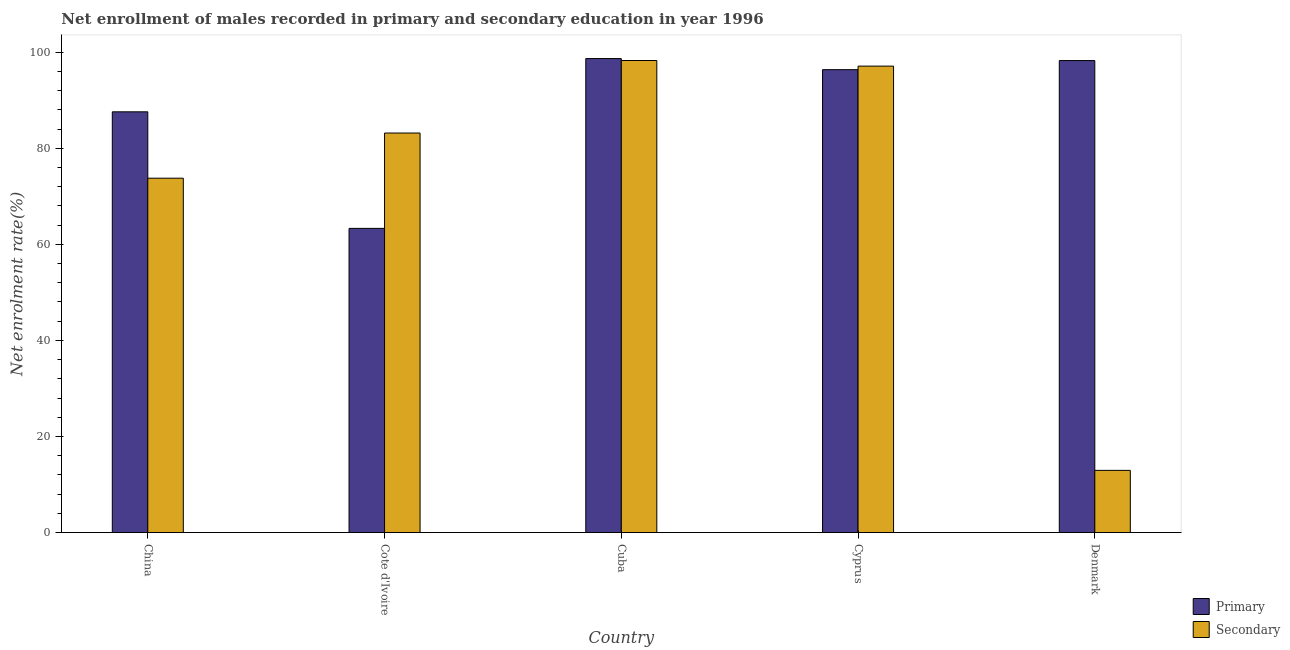Are the number of bars on each tick of the X-axis equal?
Provide a succinct answer. Yes. How many bars are there on the 5th tick from the left?
Offer a very short reply. 2. How many bars are there on the 3rd tick from the right?
Provide a short and direct response. 2. What is the enrollment rate in secondary education in Cote d'Ivoire?
Your response must be concise. 83.17. Across all countries, what is the maximum enrollment rate in secondary education?
Give a very brief answer. 98.27. Across all countries, what is the minimum enrollment rate in primary education?
Give a very brief answer. 63.32. In which country was the enrollment rate in primary education maximum?
Your answer should be very brief. Cuba. In which country was the enrollment rate in primary education minimum?
Offer a very short reply. Cote d'Ivoire. What is the total enrollment rate in secondary education in the graph?
Make the answer very short. 365.25. What is the difference between the enrollment rate in primary education in Cote d'Ivoire and that in Cyprus?
Provide a short and direct response. -33.04. What is the difference between the enrollment rate in primary education in Denmark and the enrollment rate in secondary education in China?
Your response must be concise. 24.49. What is the average enrollment rate in primary education per country?
Give a very brief answer. 88.84. What is the difference between the enrollment rate in secondary education and enrollment rate in primary education in Cote d'Ivoire?
Provide a succinct answer. 19.85. What is the ratio of the enrollment rate in primary education in Cote d'Ivoire to that in Cyprus?
Your response must be concise. 0.66. Is the enrollment rate in secondary education in Cote d'Ivoire less than that in Cyprus?
Ensure brevity in your answer.  Yes. What is the difference between the highest and the second highest enrollment rate in primary education?
Offer a terse response. 0.41. What is the difference between the highest and the lowest enrollment rate in primary education?
Ensure brevity in your answer.  35.34. Is the sum of the enrollment rate in primary education in Cote d'Ivoire and Cuba greater than the maximum enrollment rate in secondary education across all countries?
Your response must be concise. Yes. What does the 1st bar from the left in Denmark represents?
Offer a very short reply. Primary. What does the 1st bar from the right in Denmark represents?
Offer a terse response. Secondary. Are all the bars in the graph horizontal?
Your answer should be very brief. No. What is the difference between two consecutive major ticks on the Y-axis?
Offer a very short reply. 20. How many legend labels are there?
Give a very brief answer. 2. How are the legend labels stacked?
Provide a succinct answer. Vertical. What is the title of the graph?
Your response must be concise. Net enrollment of males recorded in primary and secondary education in year 1996. Does "Frequency of shipment arrival" appear as one of the legend labels in the graph?
Your answer should be very brief. No. What is the label or title of the X-axis?
Make the answer very short. Country. What is the label or title of the Y-axis?
Give a very brief answer. Net enrolment rate(%). What is the Net enrolment rate(%) in Primary in China?
Your response must be concise. 87.58. What is the Net enrolment rate(%) in Secondary in China?
Your answer should be very brief. 73.77. What is the Net enrolment rate(%) in Primary in Cote d'Ivoire?
Keep it short and to the point. 63.32. What is the Net enrolment rate(%) of Secondary in Cote d'Ivoire?
Provide a short and direct response. 83.17. What is the Net enrolment rate(%) of Primary in Cuba?
Ensure brevity in your answer.  98.67. What is the Net enrolment rate(%) of Secondary in Cuba?
Your answer should be compact. 98.27. What is the Net enrolment rate(%) of Primary in Cyprus?
Your answer should be very brief. 96.36. What is the Net enrolment rate(%) in Secondary in Cyprus?
Keep it short and to the point. 97.1. What is the Net enrolment rate(%) in Primary in Denmark?
Make the answer very short. 98.25. What is the Net enrolment rate(%) of Secondary in Denmark?
Provide a succinct answer. 12.95. Across all countries, what is the maximum Net enrolment rate(%) in Primary?
Ensure brevity in your answer.  98.67. Across all countries, what is the maximum Net enrolment rate(%) in Secondary?
Give a very brief answer. 98.27. Across all countries, what is the minimum Net enrolment rate(%) of Primary?
Provide a short and direct response. 63.32. Across all countries, what is the minimum Net enrolment rate(%) in Secondary?
Provide a short and direct response. 12.95. What is the total Net enrolment rate(%) in Primary in the graph?
Keep it short and to the point. 444.19. What is the total Net enrolment rate(%) of Secondary in the graph?
Provide a short and direct response. 365.25. What is the difference between the Net enrolment rate(%) of Primary in China and that in Cote d'Ivoire?
Provide a short and direct response. 24.26. What is the difference between the Net enrolment rate(%) of Secondary in China and that in Cote d'Ivoire?
Make the answer very short. -9.4. What is the difference between the Net enrolment rate(%) of Primary in China and that in Cuba?
Ensure brevity in your answer.  -11.08. What is the difference between the Net enrolment rate(%) of Secondary in China and that in Cuba?
Provide a succinct answer. -24.5. What is the difference between the Net enrolment rate(%) in Primary in China and that in Cyprus?
Your response must be concise. -8.78. What is the difference between the Net enrolment rate(%) in Secondary in China and that in Cyprus?
Your answer should be very brief. -23.33. What is the difference between the Net enrolment rate(%) in Primary in China and that in Denmark?
Provide a succinct answer. -10.67. What is the difference between the Net enrolment rate(%) of Secondary in China and that in Denmark?
Make the answer very short. 60.82. What is the difference between the Net enrolment rate(%) of Primary in Cote d'Ivoire and that in Cuba?
Make the answer very short. -35.34. What is the difference between the Net enrolment rate(%) of Secondary in Cote d'Ivoire and that in Cuba?
Give a very brief answer. -15.1. What is the difference between the Net enrolment rate(%) of Primary in Cote d'Ivoire and that in Cyprus?
Provide a short and direct response. -33.04. What is the difference between the Net enrolment rate(%) in Secondary in Cote d'Ivoire and that in Cyprus?
Ensure brevity in your answer.  -13.93. What is the difference between the Net enrolment rate(%) of Primary in Cote d'Ivoire and that in Denmark?
Offer a terse response. -34.93. What is the difference between the Net enrolment rate(%) of Secondary in Cote d'Ivoire and that in Denmark?
Keep it short and to the point. 70.22. What is the difference between the Net enrolment rate(%) of Primary in Cuba and that in Cyprus?
Give a very brief answer. 2.31. What is the difference between the Net enrolment rate(%) of Secondary in Cuba and that in Cyprus?
Your answer should be compact. 1.17. What is the difference between the Net enrolment rate(%) of Primary in Cuba and that in Denmark?
Provide a short and direct response. 0.41. What is the difference between the Net enrolment rate(%) in Secondary in Cuba and that in Denmark?
Ensure brevity in your answer.  85.31. What is the difference between the Net enrolment rate(%) in Primary in Cyprus and that in Denmark?
Keep it short and to the point. -1.89. What is the difference between the Net enrolment rate(%) in Secondary in Cyprus and that in Denmark?
Offer a terse response. 84.15. What is the difference between the Net enrolment rate(%) in Primary in China and the Net enrolment rate(%) in Secondary in Cote d'Ivoire?
Give a very brief answer. 4.41. What is the difference between the Net enrolment rate(%) of Primary in China and the Net enrolment rate(%) of Secondary in Cuba?
Offer a terse response. -10.68. What is the difference between the Net enrolment rate(%) in Primary in China and the Net enrolment rate(%) in Secondary in Cyprus?
Keep it short and to the point. -9.51. What is the difference between the Net enrolment rate(%) of Primary in China and the Net enrolment rate(%) of Secondary in Denmark?
Make the answer very short. 74.63. What is the difference between the Net enrolment rate(%) of Primary in Cote d'Ivoire and the Net enrolment rate(%) of Secondary in Cuba?
Your response must be concise. -34.94. What is the difference between the Net enrolment rate(%) of Primary in Cote d'Ivoire and the Net enrolment rate(%) of Secondary in Cyprus?
Keep it short and to the point. -33.77. What is the difference between the Net enrolment rate(%) in Primary in Cote d'Ivoire and the Net enrolment rate(%) in Secondary in Denmark?
Your response must be concise. 50.37. What is the difference between the Net enrolment rate(%) of Primary in Cuba and the Net enrolment rate(%) of Secondary in Cyprus?
Provide a short and direct response. 1.57. What is the difference between the Net enrolment rate(%) of Primary in Cuba and the Net enrolment rate(%) of Secondary in Denmark?
Provide a succinct answer. 85.72. What is the difference between the Net enrolment rate(%) in Primary in Cyprus and the Net enrolment rate(%) in Secondary in Denmark?
Provide a short and direct response. 83.41. What is the average Net enrolment rate(%) in Primary per country?
Offer a terse response. 88.84. What is the average Net enrolment rate(%) in Secondary per country?
Give a very brief answer. 73.05. What is the difference between the Net enrolment rate(%) of Primary and Net enrolment rate(%) of Secondary in China?
Your answer should be compact. 13.82. What is the difference between the Net enrolment rate(%) of Primary and Net enrolment rate(%) of Secondary in Cote d'Ivoire?
Your answer should be compact. -19.85. What is the difference between the Net enrolment rate(%) of Primary and Net enrolment rate(%) of Secondary in Cuba?
Offer a very short reply. 0.4. What is the difference between the Net enrolment rate(%) of Primary and Net enrolment rate(%) of Secondary in Cyprus?
Offer a very short reply. -0.74. What is the difference between the Net enrolment rate(%) of Primary and Net enrolment rate(%) of Secondary in Denmark?
Provide a short and direct response. 85.3. What is the ratio of the Net enrolment rate(%) of Primary in China to that in Cote d'Ivoire?
Give a very brief answer. 1.38. What is the ratio of the Net enrolment rate(%) in Secondary in China to that in Cote d'Ivoire?
Ensure brevity in your answer.  0.89. What is the ratio of the Net enrolment rate(%) of Primary in China to that in Cuba?
Keep it short and to the point. 0.89. What is the ratio of the Net enrolment rate(%) of Secondary in China to that in Cuba?
Your answer should be compact. 0.75. What is the ratio of the Net enrolment rate(%) of Primary in China to that in Cyprus?
Provide a succinct answer. 0.91. What is the ratio of the Net enrolment rate(%) of Secondary in China to that in Cyprus?
Offer a terse response. 0.76. What is the ratio of the Net enrolment rate(%) of Primary in China to that in Denmark?
Provide a succinct answer. 0.89. What is the ratio of the Net enrolment rate(%) of Secondary in China to that in Denmark?
Your answer should be very brief. 5.7. What is the ratio of the Net enrolment rate(%) in Primary in Cote d'Ivoire to that in Cuba?
Provide a short and direct response. 0.64. What is the ratio of the Net enrolment rate(%) of Secondary in Cote d'Ivoire to that in Cuba?
Your answer should be very brief. 0.85. What is the ratio of the Net enrolment rate(%) of Primary in Cote d'Ivoire to that in Cyprus?
Your answer should be very brief. 0.66. What is the ratio of the Net enrolment rate(%) of Secondary in Cote d'Ivoire to that in Cyprus?
Ensure brevity in your answer.  0.86. What is the ratio of the Net enrolment rate(%) of Primary in Cote d'Ivoire to that in Denmark?
Offer a terse response. 0.64. What is the ratio of the Net enrolment rate(%) in Secondary in Cote d'Ivoire to that in Denmark?
Give a very brief answer. 6.42. What is the ratio of the Net enrolment rate(%) in Primary in Cuba to that in Cyprus?
Make the answer very short. 1.02. What is the ratio of the Net enrolment rate(%) of Secondary in Cuba to that in Cyprus?
Make the answer very short. 1.01. What is the ratio of the Net enrolment rate(%) of Secondary in Cuba to that in Denmark?
Offer a very short reply. 7.59. What is the ratio of the Net enrolment rate(%) in Primary in Cyprus to that in Denmark?
Keep it short and to the point. 0.98. What is the ratio of the Net enrolment rate(%) of Secondary in Cyprus to that in Denmark?
Your answer should be very brief. 7.5. What is the difference between the highest and the second highest Net enrolment rate(%) in Primary?
Give a very brief answer. 0.41. What is the difference between the highest and the second highest Net enrolment rate(%) in Secondary?
Keep it short and to the point. 1.17. What is the difference between the highest and the lowest Net enrolment rate(%) of Primary?
Give a very brief answer. 35.34. What is the difference between the highest and the lowest Net enrolment rate(%) in Secondary?
Provide a short and direct response. 85.31. 